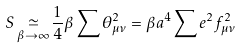<formula> <loc_0><loc_0><loc_500><loc_500>S \mathop \simeq _ { \beta \to \infty } \frac { 1 } { 4 } \beta \sum \theta _ { \mu \nu } ^ { 2 } = \beta a ^ { 4 } \sum e ^ { 2 } f ^ { 2 } _ { \mu \nu }</formula> 